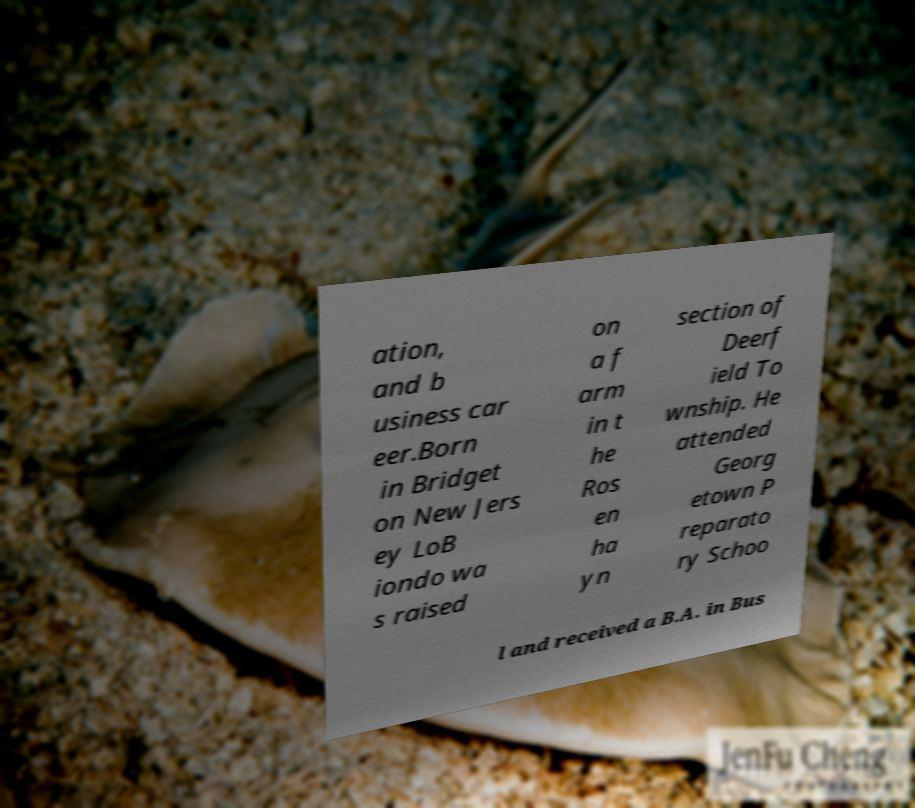Please read and relay the text visible in this image. What does it say? ation, and b usiness car eer.Born in Bridget on New Jers ey LoB iondo wa s raised on a f arm in t he Ros en ha yn section of Deerf ield To wnship. He attended Georg etown P reparato ry Schoo l and received a B.A. in Bus 